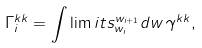Convert formula to latex. <formula><loc_0><loc_0><loc_500><loc_500>\Gamma _ { i } ^ { k k } = \int \lim i t s _ { w _ { i } } ^ { w _ { i + 1 } } d w \, \gamma ^ { k k } ,</formula> 